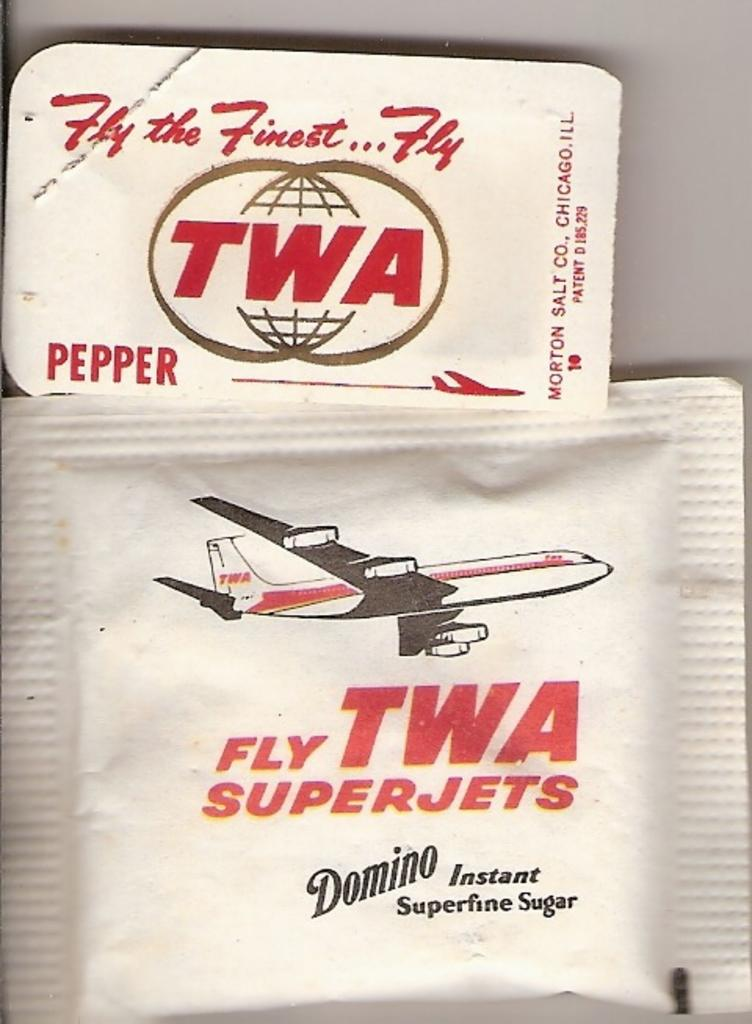<image>
Offer a succinct explanation of the picture presented. A Domino instant superfine sugar packet and a pepper packet from TWA. 